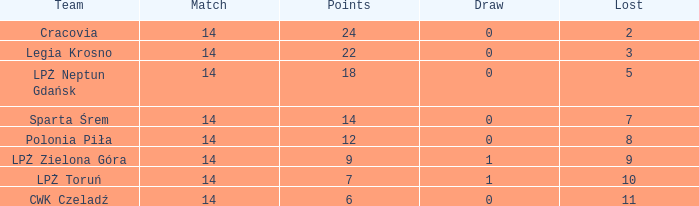What is the highest loss with points less than 7? 11.0. 